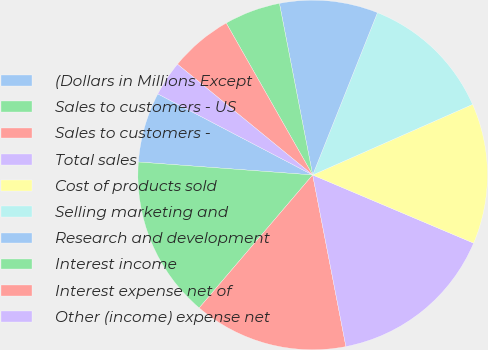Convert chart to OTSL. <chart><loc_0><loc_0><loc_500><loc_500><pie_chart><fcel>(Dollars in Millions Except<fcel>Sales to customers - US<fcel>Sales to customers -<fcel>Total sales<fcel>Cost of products sold<fcel>Selling marketing and<fcel>Research and development<fcel>Interest income<fcel>Interest expense net of<fcel>Other (income) expense net<nl><fcel>6.49%<fcel>14.94%<fcel>14.29%<fcel>15.58%<fcel>12.99%<fcel>12.34%<fcel>9.09%<fcel>5.19%<fcel>5.84%<fcel>3.25%<nl></chart> 